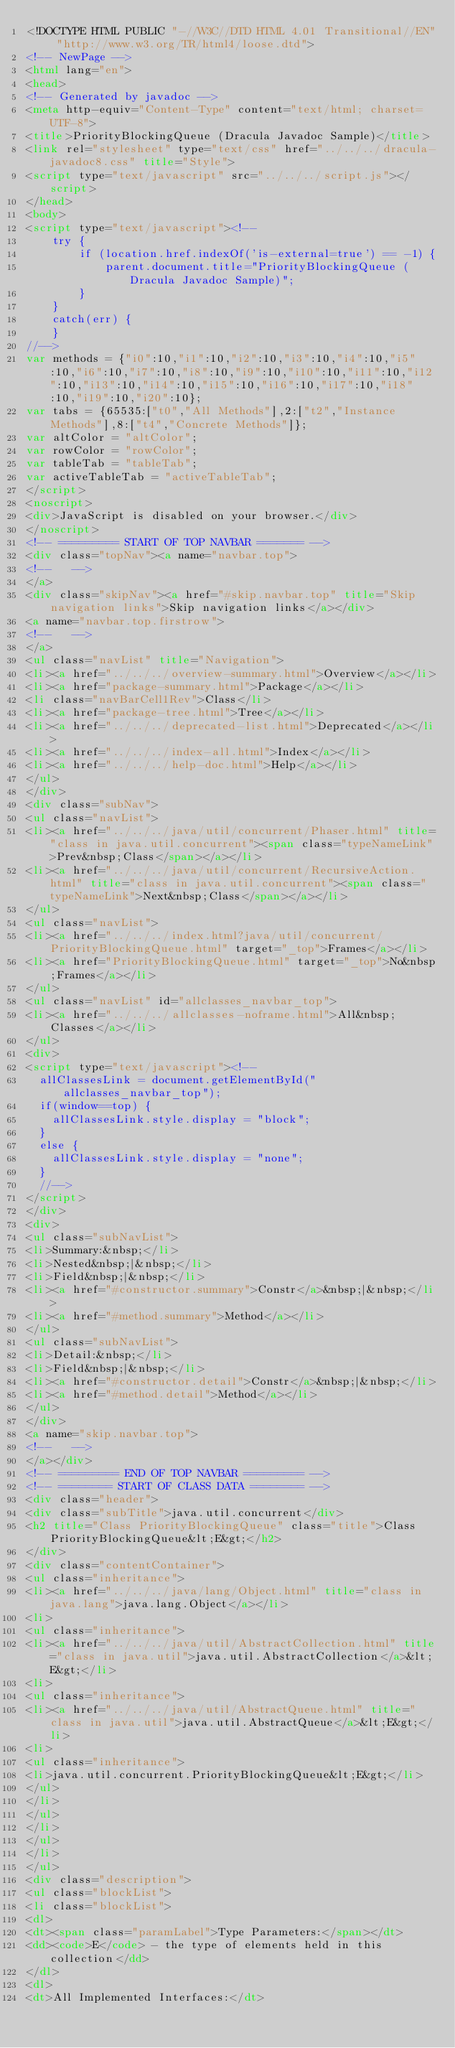Convert code to text. <code><loc_0><loc_0><loc_500><loc_500><_HTML_><!DOCTYPE HTML PUBLIC "-//W3C//DTD HTML 4.01 Transitional//EN" "http://www.w3.org/TR/html4/loose.dtd">
<!-- NewPage -->
<html lang="en">
<head>
<!-- Generated by javadoc -->
<meta http-equiv="Content-Type" content="text/html; charset=UTF-8">
<title>PriorityBlockingQueue (Dracula Javadoc Sample)</title>
<link rel="stylesheet" type="text/css" href="../../../dracula-javadoc8.css" title="Style">
<script type="text/javascript" src="../../../script.js"></script>
</head>
<body>
<script type="text/javascript"><!--
    try {
        if (location.href.indexOf('is-external=true') == -1) {
            parent.document.title="PriorityBlockingQueue (Dracula Javadoc Sample)";
        }
    }
    catch(err) {
    }
//-->
var methods = {"i0":10,"i1":10,"i2":10,"i3":10,"i4":10,"i5":10,"i6":10,"i7":10,"i8":10,"i9":10,"i10":10,"i11":10,"i12":10,"i13":10,"i14":10,"i15":10,"i16":10,"i17":10,"i18":10,"i19":10,"i20":10};
var tabs = {65535:["t0","All Methods"],2:["t2","Instance Methods"],8:["t4","Concrete Methods"]};
var altColor = "altColor";
var rowColor = "rowColor";
var tableTab = "tableTab";
var activeTableTab = "activeTableTab";
</script>
<noscript>
<div>JavaScript is disabled on your browser.</div>
</noscript>
<!-- ========= START OF TOP NAVBAR ======= -->
<div class="topNav"><a name="navbar.top">
<!--   -->
</a>
<div class="skipNav"><a href="#skip.navbar.top" title="Skip navigation links">Skip navigation links</a></div>
<a name="navbar.top.firstrow">
<!--   -->
</a>
<ul class="navList" title="Navigation">
<li><a href="../../../overview-summary.html">Overview</a></li>
<li><a href="package-summary.html">Package</a></li>
<li class="navBarCell1Rev">Class</li>
<li><a href="package-tree.html">Tree</a></li>
<li><a href="../../../deprecated-list.html">Deprecated</a></li>
<li><a href="../../../index-all.html">Index</a></li>
<li><a href="../../../help-doc.html">Help</a></li>
</ul>
</div>
<div class="subNav">
<ul class="navList">
<li><a href="../../../java/util/concurrent/Phaser.html" title="class in java.util.concurrent"><span class="typeNameLink">Prev&nbsp;Class</span></a></li>
<li><a href="../../../java/util/concurrent/RecursiveAction.html" title="class in java.util.concurrent"><span class="typeNameLink">Next&nbsp;Class</span></a></li>
</ul>
<ul class="navList">
<li><a href="../../../index.html?java/util/concurrent/PriorityBlockingQueue.html" target="_top">Frames</a></li>
<li><a href="PriorityBlockingQueue.html" target="_top">No&nbsp;Frames</a></li>
</ul>
<ul class="navList" id="allclasses_navbar_top">
<li><a href="../../../allclasses-noframe.html">All&nbsp;Classes</a></li>
</ul>
<div>
<script type="text/javascript"><!--
  allClassesLink = document.getElementById("allclasses_navbar_top");
  if(window==top) {
    allClassesLink.style.display = "block";
  }
  else {
    allClassesLink.style.display = "none";
  }
  //-->
</script>
</div>
<div>
<ul class="subNavList">
<li>Summary:&nbsp;</li>
<li>Nested&nbsp;|&nbsp;</li>
<li>Field&nbsp;|&nbsp;</li>
<li><a href="#constructor.summary">Constr</a>&nbsp;|&nbsp;</li>
<li><a href="#method.summary">Method</a></li>
</ul>
<ul class="subNavList">
<li>Detail:&nbsp;</li>
<li>Field&nbsp;|&nbsp;</li>
<li><a href="#constructor.detail">Constr</a>&nbsp;|&nbsp;</li>
<li><a href="#method.detail">Method</a></li>
</ul>
</div>
<a name="skip.navbar.top">
<!--   -->
</a></div>
<!-- ========= END OF TOP NAVBAR ========= -->
<!-- ======== START OF CLASS DATA ======== -->
<div class="header">
<div class="subTitle">java.util.concurrent</div>
<h2 title="Class PriorityBlockingQueue" class="title">Class PriorityBlockingQueue&lt;E&gt;</h2>
</div>
<div class="contentContainer">
<ul class="inheritance">
<li><a href="../../../java/lang/Object.html" title="class in java.lang">java.lang.Object</a></li>
<li>
<ul class="inheritance">
<li><a href="../../../java/util/AbstractCollection.html" title="class in java.util">java.util.AbstractCollection</a>&lt;E&gt;</li>
<li>
<ul class="inheritance">
<li><a href="../../../java/util/AbstractQueue.html" title="class in java.util">java.util.AbstractQueue</a>&lt;E&gt;</li>
<li>
<ul class="inheritance">
<li>java.util.concurrent.PriorityBlockingQueue&lt;E&gt;</li>
</ul>
</li>
</ul>
</li>
</ul>
</li>
</ul>
<div class="description">
<ul class="blockList">
<li class="blockList">
<dl>
<dt><span class="paramLabel">Type Parameters:</span></dt>
<dd><code>E</code> - the type of elements held in this collection</dd>
</dl>
<dl>
<dt>All Implemented Interfaces:</dt></code> 